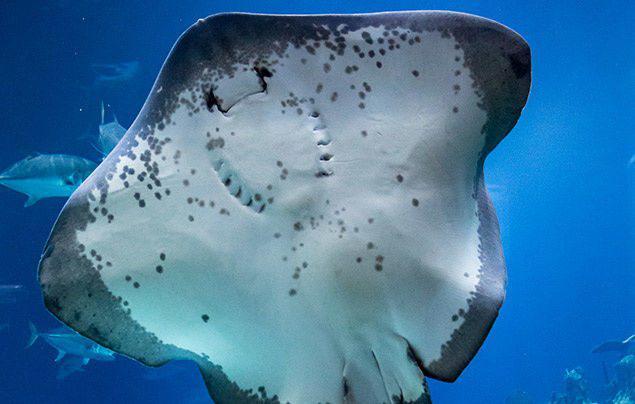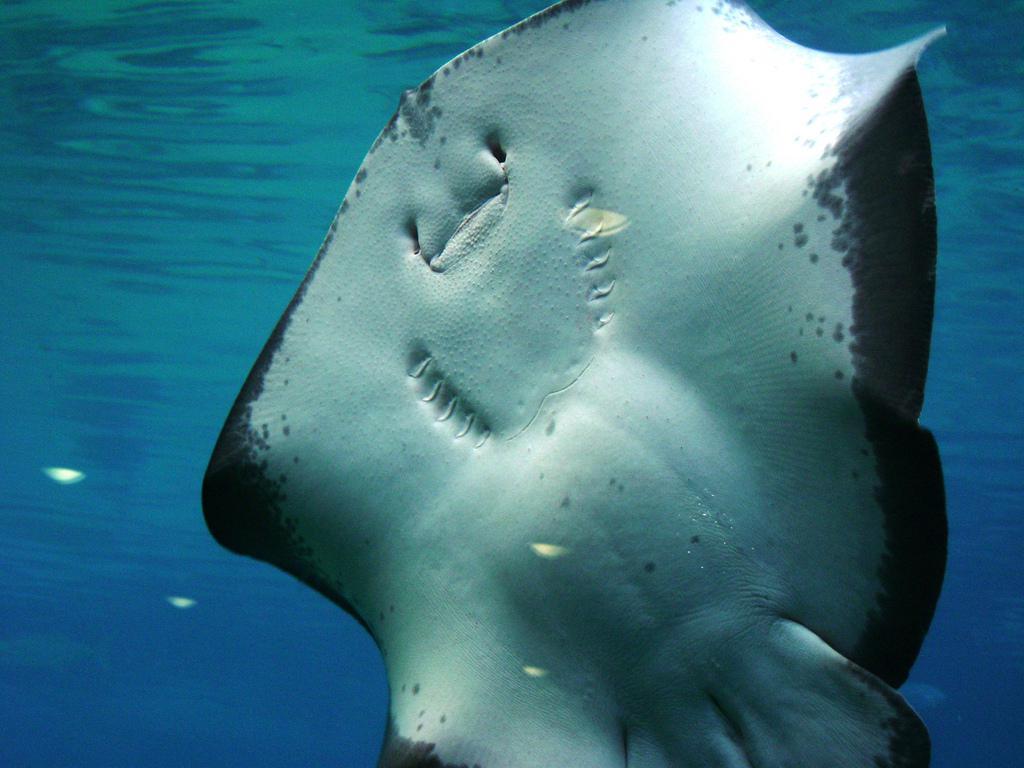The first image is the image on the left, the second image is the image on the right. Considering the images on both sides, is "There is exactly one manta ray." valid? Answer yes or no. No. The first image is the image on the left, the second image is the image on the right. For the images shown, is this caption "The right image shows the complete underbelly of a manta ray." true? Answer yes or no. Yes. 